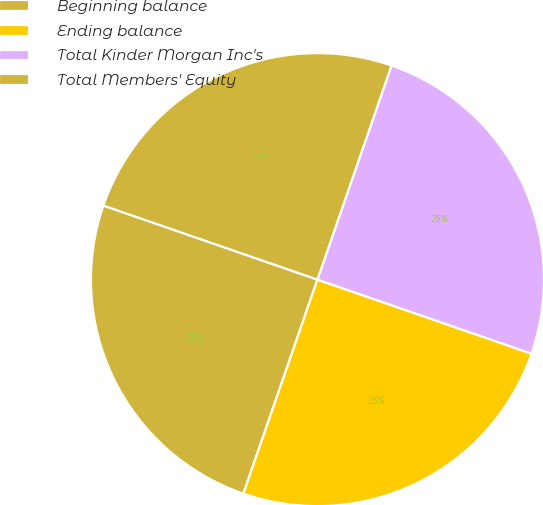Convert chart to OTSL. <chart><loc_0><loc_0><loc_500><loc_500><pie_chart><fcel>Beginning balance<fcel>Ending balance<fcel>Total Kinder Morgan Inc's<fcel>Total Members' Equity<nl><fcel>25.0%<fcel>25.0%<fcel>25.0%<fcel>25.0%<nl></chart> 